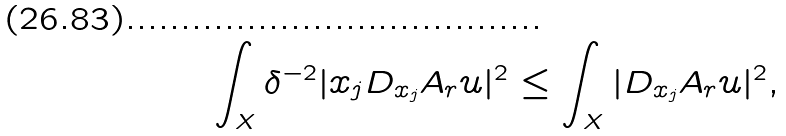Convert formula to latex. <formula><loc_0><loc_0><loc_500><loc_500>\int _ { X } \delta ^ { - 2 } | x _ { j } D _ { x _ { j } } A _ { r } u | ^ { 2 } \leq \int _ { X } | D _ { x _ { j } } A _ { r } u | ^ { 2 } ,</formula> 